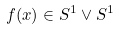<formula> <loc_0><loc_0><loc_500><loc_500>f ( x ) \in S ^ { 1 } \vee S ^ { 1 }</formula> 